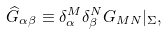Convert formula to latex. <formula><loc_0><loc_0><loc_500><loc_500>\widehat { G } _ { \alpha \beta } \equiv \delta _ { \alpha } ^ { M } \delta _ { \beta } ^ { N } G _ { M N } | _ { \Sigma } ,</formula> 